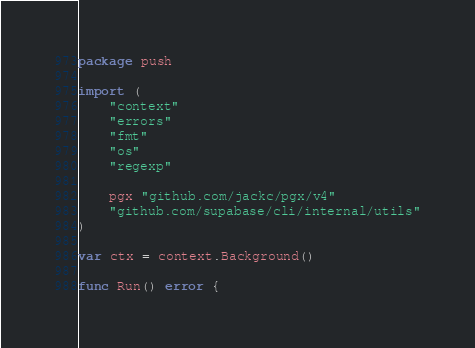Convert code to text. <code><loc_0><loc_0><loc_500><loc_500><_Go_>package push

import (
	"context"
	"errors"
	"fmt"
	"os"
	"regexp"

	pgx "github.com/jackc/pgx/v4"
	"github.com/supabase/cli/internal/utils"
)

var ctx = context.Background()

func Run() error {</code> 